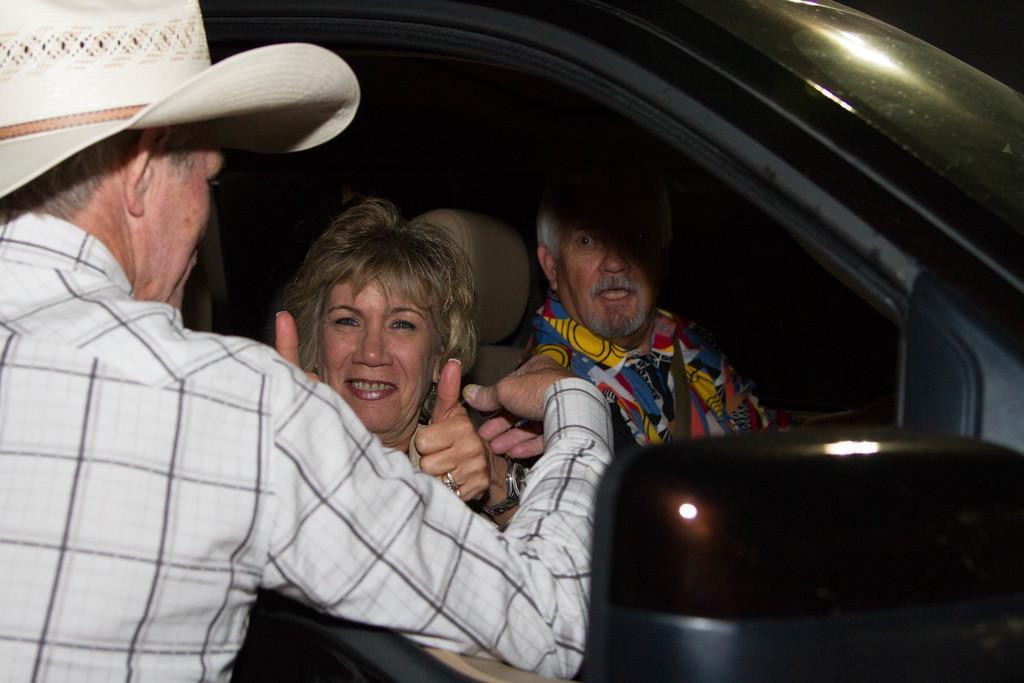Can you describe this image briefly? In this image we can see three persons, two of them are sitting in a car, one person is wearing a hat, also we can see a side mirror. 